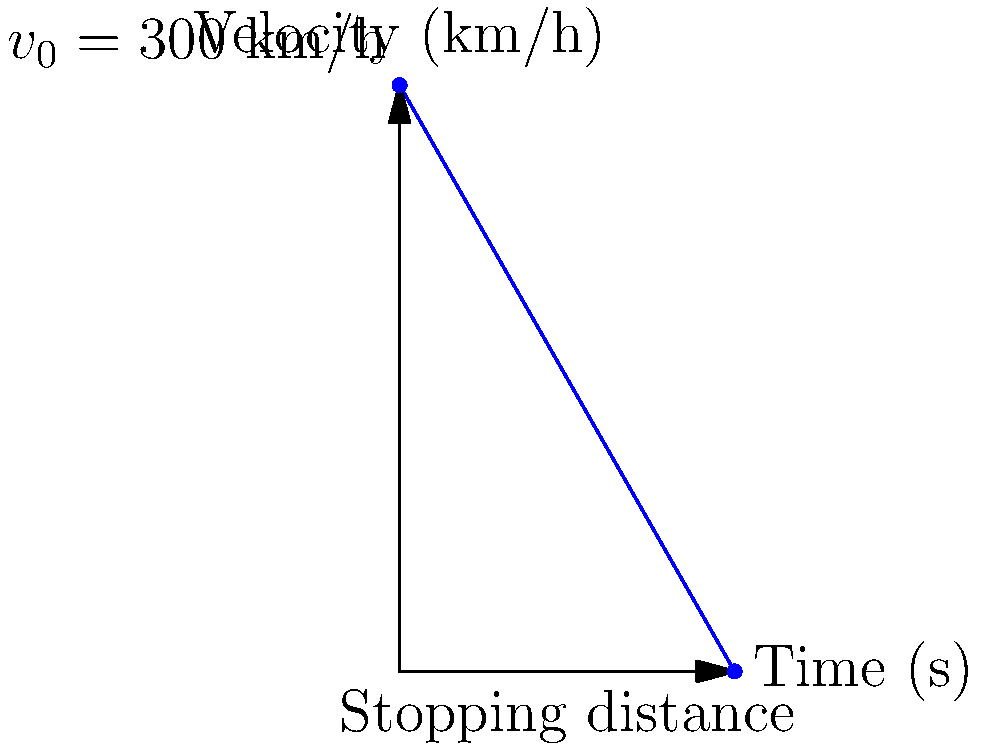A Formula One car is traveling at an initial velocity of 300 km/h when the driver applies the brakes, causing a constant deceleration of 25 m/s². Calculate the braking distance required for the car to come to a complete stop. (Assume the track is level and ignore air resistance.) To solve this problem, we'll follow these steps:

1. Convert the initial velocity from km/h to m/s:
   $v_0 = 300 \text{ km/h} = 300 \times \frac{1000 \text{ m}}{3600 \text{ s}} = 83.33 \text{ m/s}$

2. Use the equation for braking distance with constant deceleration:
   $s = -\frac{v_0^2}{2a}$

   Where:
   $s$ is the braking distance
   $v_0$ is the initial velocity
   $a$ is the deceleration (negative acceleration)

3. Substitute the values:
   $s = -\frac{(83.33 \text{ m/s})^2}{2(-25 \text{ m/s}^2)}$

4. Calculate:
   $s = \frac{6943.89 \text{ m}^2/\text{s}^2}{50 \text{ m/s}^2} = 138.88 \text{ m}$

5. Round to two decimal places:
   $s \approx 138.89 \text{ m}$

Therefore, the Formula One car requires approximately 138.89 meters to come to a complete stop under the given conditions.
Answer: 138.89 m 